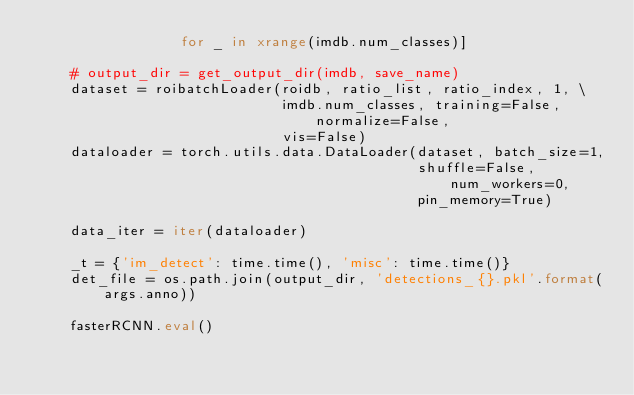Convert code to text. <code><loc_0><loc_0><loc_500><loc_500><_Python_>                 for _ in xrange(imdb.num_classes)]

    # output_dir = get_output_dir(imdb, save_name)
    dataset = roibatchLoader(roidb, ratio_list, ratio_index, 1, \
                             imdb.num_classes, training=False, normalize=False,
                             vis=False)
    dataloader = torch.utils.data.DataLoader(dataset, batch_size=1,
                                             shuffle=False, num_workers=0,
                                             pin_memory=True)

    data_iter = iter(dataloader)

    _t = {'im_detect': time.time(), 'misc': time.time()}
    det_file = os.path.join(output_dir, 'detections_{}.pkl'.format(args.anno))

    fasterRCNN.eval()</code> 